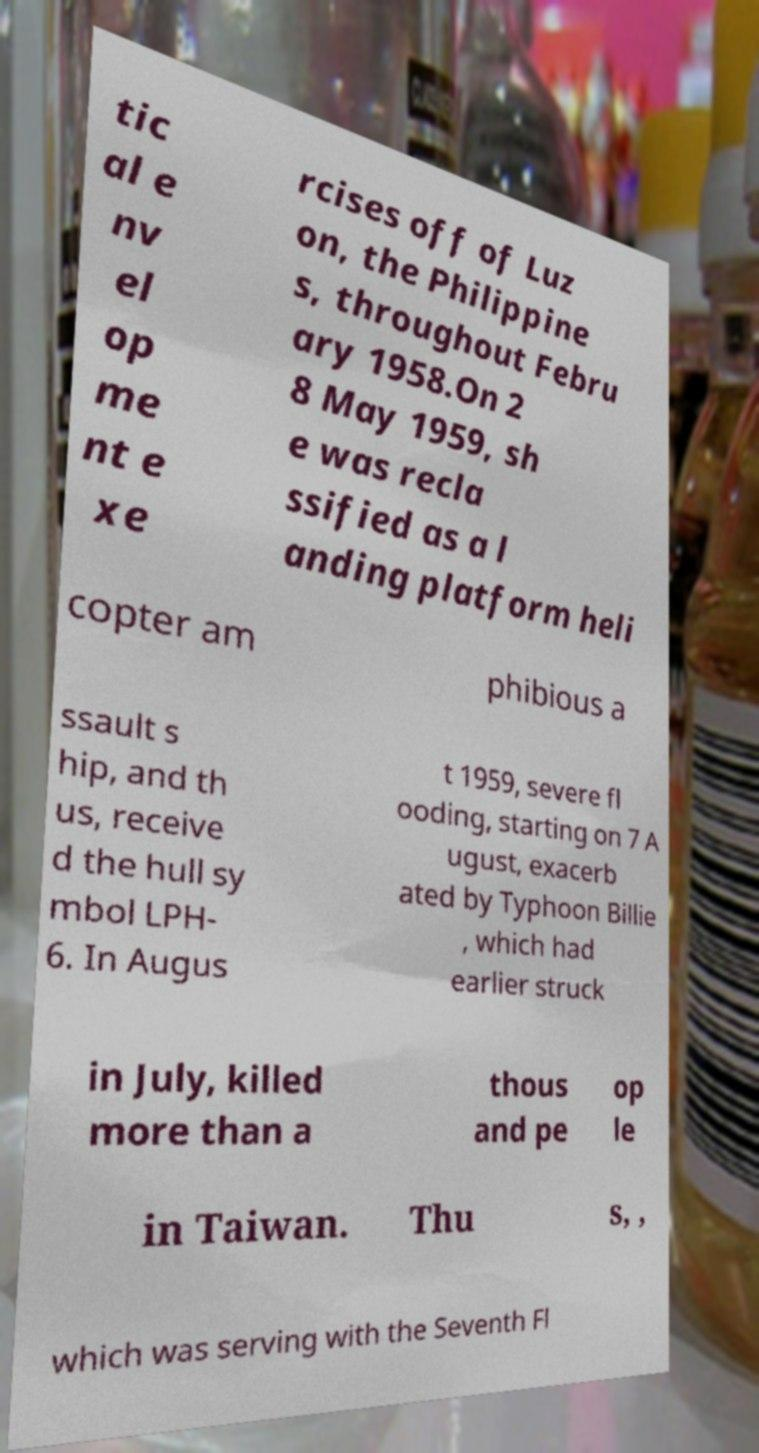What messages or text are displayed in this image? I need them in a readable, typed format. tic al e nv el op me nt e xe rcises off of Luz on, the Philippine s, throughout Febru ary 1958.On 2 8 May 1959, sh e was recla ssified as a l anding platform heli copter am phibious a ssault s hip, and th us, receive d the hull sy mbol LPH- 6. In Augus t 1959, severe fl ooding, starting on 7 A ugust, exacerb ated by Typhoon Billie , which had earlier struck in July, killed more than a thous and pe op le in Taiwan. Thu s, , which was serving with the Seventh Fl 